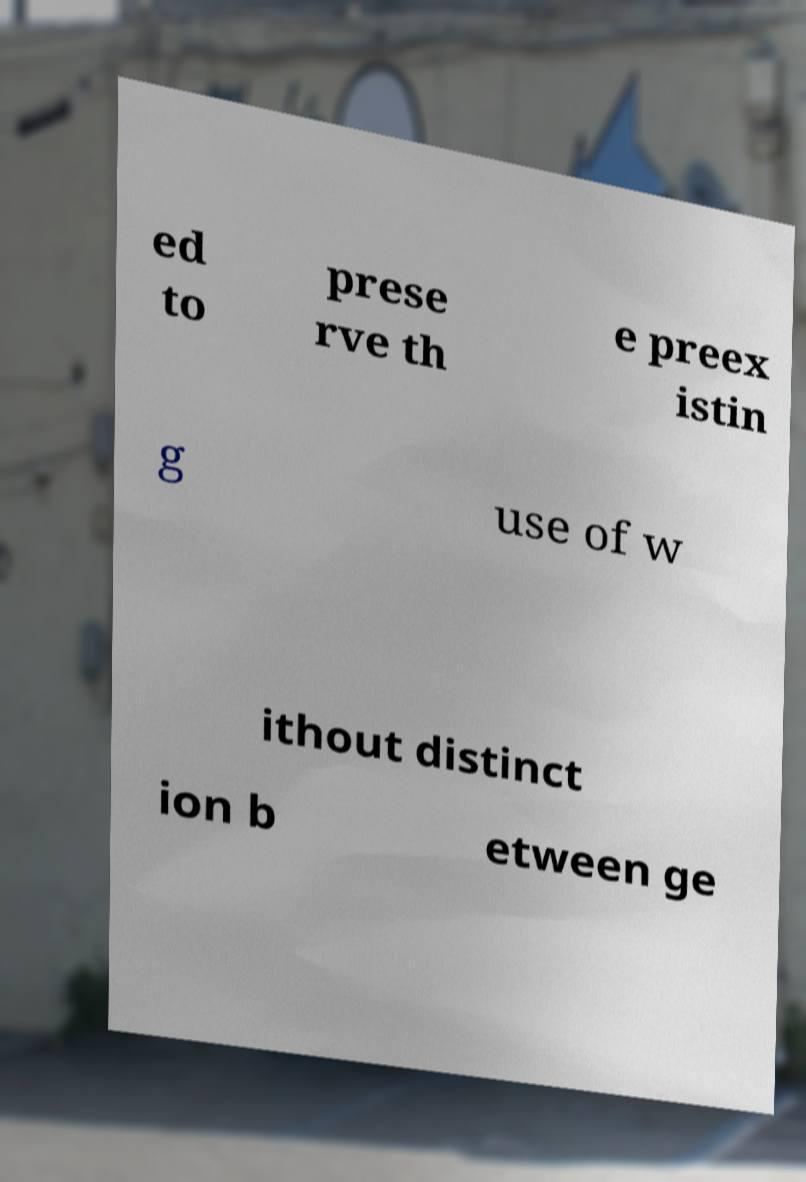For documentation purposes, I need the text within this image transcribed. Could you provide that? ed to prese rve th e preex istin g use of w ithout distinct ion b etween ge 